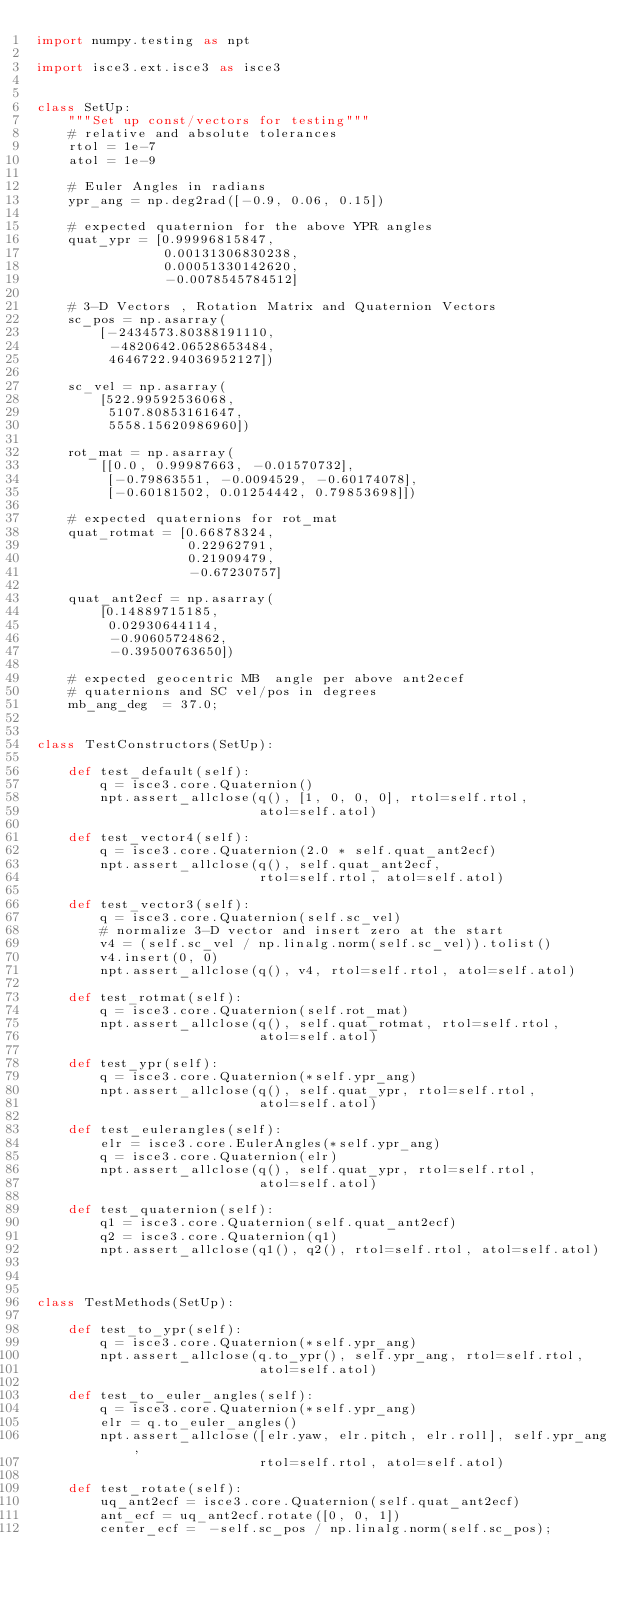<code> <loc_0><loc_0><loc_500><loc_500><_Python_>import numpy.testing as npt

import isce3.ext.isce3 as isce3


class SetUp:
    """Set up const/vectors for testing"""
    # relative and absolute tolerances
    rtol = 1e-7
    atol = 1e-9

    # Euler Angles in radians
    ypr_ang = np.deg2rad([-0.9, 0.06, 0.15])

    # expected quaternion for the above YPR angles
    quat_ypr = [0.99996815847,
                0.00131306830238,
                0.00051330142620,
                -0.0078545784512]

    # 3-D Vectors , Rotation Matrix and Quaternion Vectors
    sc_pos = np.asarray(
        [-2434573.80388191110,
         -4820642.06528653484,
         4646722.94036952127])

    sc_vel = np.asarray(
        [522.99592536068,
         5107.80853161647,
         5558.15620986960])

    rot_mat = np.asarray(
        [[0.0, 0.99987663, -0.01570732],
         [-0.79863551, -0.0094529, -0.60174078],
         [-0.60181502, 0.01254442, 0.79853698]])

    # expected quaternions for rot_mat
    quat_rotmat = [0.66878324,
                   0.22962791, 
                   0.21909479,
                   -0.67230757]

    quat_ant2ecf = np.asarray(
        [0.14889715185,
         0.02930644114,
         -0.90605724862,
         -0.39500763650])

    # expected geocentric MB  angle per above ant2ecef 
    # quaternions and SC vel/pos in degrees 
    mb_ang_deg  = 37.0;   

    
class TestConstructors(SetUp):

    def test_default(self):
        q = isce3.core.Quaternion()
        npt.assert_allclose(q(), [1, 0, 0, 0], rtol=self.rtol,
                            atol=self.atol)

    def test_vector4(self):
        q = isce3.core.Quaternion(2.0 * self.quat_ant2ecf)
        npt.assert_allclose(q(), self.quat_ant2ecf,
                            rtol=self.rtol, atol=self.atol)

    def test_vector3(self):
        q = isce3.core.Quaternion(self.sc_vel)
        # normalize 3-D vector and insert zero at the start
        v4 = (self.sc_vel / np.linalg.norm(self.sc_vel)).tolist()
        v4.insert(0, 0)        
        npt.assert_allclose(q(), v4, rtol=self.rtol, atol=self.atol)

    def test_rotmat(self):
        q = isce3.core.Quaternion(self.rot_mat)
        npt.assert_allclose(q(), self.quat_rotmat, rtol=self.rtol,
                            atol=self.atol)

    def test_ypr(self):
        q = isce3.core.Quaternion(*self.ypr_ang)
        npt.assert_allclose(q(), self.quat_ypr, rtol=self.rtol,
                            atol=self.atol)

    def test_eulerangles(self):
        elr = isce3.core.EulerAngles(*self.ypr_ang)
        q = isce3.core.Quaternion(elr)
        npt.assert_allclose(q(), self.quat_ypr, rtol=self.rtol,
                            atol=self.atol)

    def test_quaternion(self):
        q1 = isce3.core.Quaternion(self.quat_ant2ecf)
        q2 = isce3.core.Quaternion(q1)
        npt.assert_allclose(q1(), q2(), rtol=self.rtol, atol=self.atol)

        

class TestMethods(SetUp):
    
    def test_to_ypr(self):        
        q = isce3.core.Quaternion(*self.ypr_ang)        
        npt.assert_allclose(q.to_ypr(), self.ypr_ang, rtol=self.rtol,
                            atol=self.atol)

    def test_to_euler_angles(self):
        q = isce3.core.Quaternion(*self.ypr_ang)
        elr = q.to_euler_angles()
        npt.assert_allclose([elr.yaw, elr.pitch, elr.roll], self.ypr_ang,
                            rtol=self.rtol, atol=self.atol)

    def test_rotate(self):
        uq_ant2ecf = isce3.core.Quaternion(self.quat_ant2ecf)
        ant_ecf = uq_ant2ecf.rotate([0, 0, 1])
        center_ecf =  -self.sc_pos / np.linalg.norm(self.sc_pos);</code> 